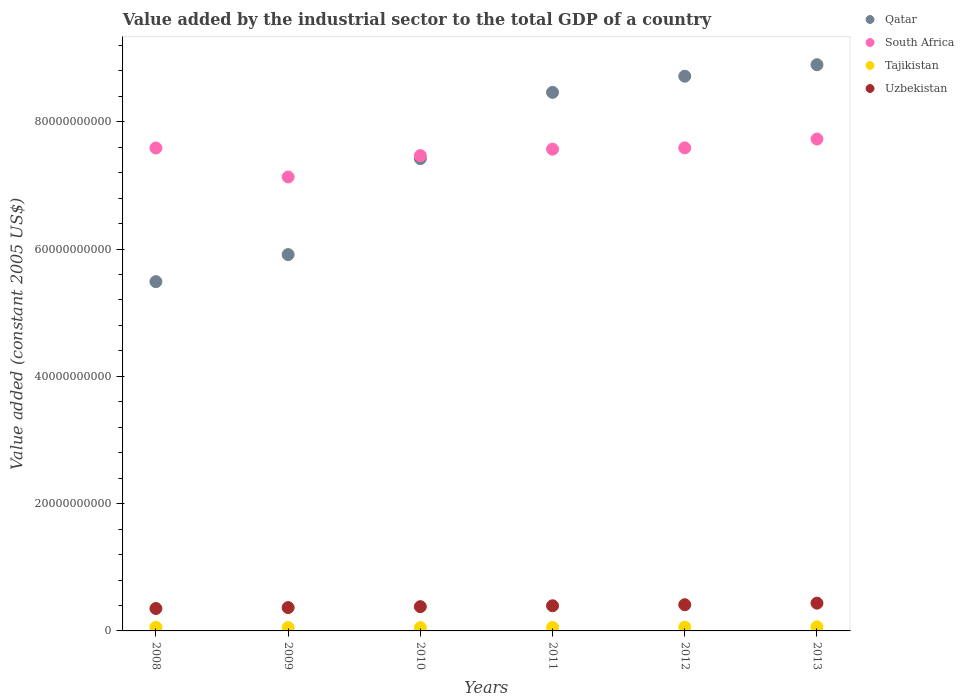What is the value added by the industrial sector in Tajikistan in 2010?
Make the answer very short. 5.19e+08. Across all years, what is the maximum value added by the industrial sector in South Africa?
Give a very brief answer. 7.73e+1. Across all years, what is the minimum value added by the industrial sector in South Africa?
Your answer should be compact. 7.13e+1. In which year was the value added by the industrial sector in Tajikistan maximum?
Ensure brevity in your answer.  2013. In which year was the value added by the industrial sector in Tajikistan minimum?
Provide a succinct answer. 2010. What is the total value added by the industrial sector in Uzbekistan in the graph?
Give a very brief answer. 2.34e+1. What is the difference between the value added by the industrial sector in Uzbekistan in 2008 and that in 2009?
Offer a very short reply. -1.44e+08. What is the difference between the value added by the industrial sector in Tajikistan in 2012 and the value added by the industrial sector in South Africa in 2008?
Your answer should be very brief. -7.53e+1. What is the average value added by the industrial sector in South Africa per year?
Offer a terse response. 7.51e+1. In the year 2010, what is the difference between the value added by the industrial sector in Uzbekistan and value added by the industrial sector in Tajikistan?
Keep it short and to the point. 3.30e+09. In how many years, is the value added by the industrial sector in South Africa greater than 48000000000 US$?
Give a very brief answer. 6. What is the ratio of the value added by the industrial sector in Tajikistan in 2008 to that in 2013?
Ensure brevity in your answer.  0.89. Is the value added by the industrial sector in Qatar in 2009 less than that in 2012?
Offer a terse response. Yes. What is the difference between the highest and the second highest value added by the industrial sector in Tajikistan?
Keep it short and to the point. 5.21e+07. What is the difference between the highest and the lowest value added by the industrial sector in South Africa?
Offer a terse response. 5.96e+09. In how many years, is the value added by the industrial sector in Tajikistan greater than the average value added by the industrial sector in Tajikistan taken over all years?
Your answer should be compact. 3. How many dotlines are there?
Your answer should be compact. 4. How many years are there in the graph?
Your response must be concise. 6. Are the values on the major ticks of Y-axis written in scientific E-notation?
Your answer should be very brief. No. Does the graph contain any zero values?
Provide a short and direct response. No. How many legend labels are there?
Provide a succinct answer. 4. What is the title of the graph?
Keep it short and to the point. Value added by the industrial sector to the total GDP of a country. What is the label or title of the X-axis?
Provide a succinct answer. Years. What is the label or title of the Y-axis?
Your response must be concise. Value added (constant 2005 US$). What is the Value added (constant 2005 US$) in Qatar in 2008?
Ensure brevity in your answer.  5.49e+1. What is the Value added (constant 2005 US$) of South Africa in 2008?
Keep it short and to the point. 7.59e+1. What is the Value added (constant 2005 US$) in Tajikistan in 2008?
Ensure brevity in your answer.  5.72e+08. What is the Value added (constant 2005 US$) in Uzbekistan in 2008?
Your answer should be compact. 3.52e+09. What is the Value added (constant 2005 US$) in Qatar in 2009?
Keep it short and to the point. 5.91e+1. What is the Value added (constant 2005 US$) of South Africa in 2009?
Your response must be concise. 7.13e+1. What is the Value added (constant 2005 US$) in Tajikistan in 2009?
Provide a succinct answer. 5.31e+08. What is the Value added (constant 2005 US$) of Uzbekistan in 2009?
Your response must be concise. 3.67e+09. What is the Value added (constant 2005 US$) in Qatar in 2010?
Provide a short and direct response. 7.42e+1. What is the Value added (constant 2005 US$) in South Africa in 2010?
Your answer should be very brief. 7.47e+1. What is the Value added (constant 2005 US$) of Tajikistan in 2010?
Provide a short and direct response. 5.19e+08. What is the Value added (constant 2005 US$) of Uzbekistan in 2010?
Offer a terse response. 3.81e+09. What is the Value added (constant 2005 US$) of Qatar in 2011?
Your response must be concise. 8.46e+1. What is the Value added (constant 2005 US$) of South Africa in 2011?
Make the answer very short. 7.57e+1. What is the Value added (constant 2005 US$) of Tajikistan in 2011?
Your answer should be compact. 5.49e+08. What is the Value added (constant 2005 US$) of Uzbekistan in 2011?
Your response must be concise. 3.95e+09. What is the Value added (constant 2005 US$) of Qatar in 2012?
Make the answer very short. 8.72e+1. What is the Value added (constant 2005 US$) in South Africa in 2012?
Keep it short and to the point. 7.59e+1. What is the Value added (constant 2005 US$) in Tajikistan in 2012?
Your response must be concise. 5.91e+08. What is the Value added (constant 2005 US$) of Uzbekistan in 2012?
Offer a terse response. 4.12e+09. What is the Value added (constant 2005 US$) of Qatar in 2013?
Provide a short and direct response. 8.90e+1. What is the Value added (constant 2005 US$) of South Africa in 2013?
Provide a succinct answer. 7.73e+1. What is the Value added (constant 2005 US$) of Tajikistan in 2013?
Keep it short and to the point. 6.43e+08. What is the Value added (constant 2005 US$) of Uzbekistan in 2013?
Give a very brief answer. 4.37e+09. Across all years, what is the maximum Value added (constant 2005 US$) of Qatar?
Make the answer very short. 8.90e+1. Across all years, what is the maximum Value added (constant 2005 US$) of South Africa?
Your response must be concise. 7.73e+1. Across all years, what is the maximum Value added (constant 2005 US$) in Tajikistan?
Your response must be concise. 6.43e+08. Across all years, what is the maximum Value added (constant 2005 US$) in Uzbekistan?
Make the answer very short. 4.37e+09. Across all years, what is the minimum Value added (constant 2005 US$) of Qatar?
Provide a succinct answer. 5.49e+1. Across all years, what is the minimum Value added (constant 2005 US$) of South Africa?
Give a very brief answer. 7.13e+1. Across all years, what is the minimum Value added (constant 2005 US$) in Tajikistan?
Your answer should be very brief. 5.19e+08. Across all years, what is the minimum Value added (constant 2005 US$) in Uzbekistan?
Make the answer very short. 3.52e+09. What is the total Value added (constant 2005 US$) of Qatar in the graph?
Give a very brief answer. 4.49e+11. What is the total Value added (constant 2005 US$) of South Africa in the graph?
Provide a succinct answer. 4.51e+11. What is the total Value added (constant 2005 US$) of Tajikistan in the graph?
Offer a terse response. 3.40e+09. What is the total Value added (constant 2005 US$) of Uzbekistan in the graph?
Make the answer very short. 2.34e+1. What is the difference between the Value added (constant 2005 US$) of Qatar in 2008 and that in 2009?
Provide a succinct answer. -4.26e+09. What is the difference between the Value added (constant 2005 US$) of South Africa in 2008 and that in 2009?
Keep it short and to the point. 4.55e+09. What is the difference between the Value added (constant 2005 US$) of Tajikistan in 2008 and that in 2009?
Give a very brief answer. 4.07e+07. What is the difference between the Value added (constant 2005 US$) of Uzbekistan in 2008 and that in 2009?
Ensure brevity in your answer.  -1.44e+08. What is the difference between the Value added (constant 2005 US$) in Qatar in 2008 and that in 2010?
Offer a very short reply. -1.93e+1. What is the difference between the Value added (constant 2005 US$) of South Africa in 2008 and that in 2010?
Provide a succinct answer. 1.19e+09. What is the difference between the Value added (constant 2005 US$) in Tajikistan in 2008 and that in 2010?
Give a very brief answer. 5.35e+07. What is the difference between the Value added (constant 2005 US$) of Uzbekistan in 2008 and that in 2010?
Offer a terse response. -2.91e+08. What is the difference between the Value added (constant 2005 US$) in Qatar in 2008 and that in 2011?
Your answer should be very brief. -2.97e+1. What is the difference between the Value added (constant 2005 US$) of South Africa in 2008 and that in 2011?
Give a very brief answer. 1.84e+08. What is the difference between the Value added (constant 2005 US$) in Tajikistan in 2008 and that in 2011?
Your answer should be very brief. 2.35e+07. What is the difference between the Value added (constant 2005 US$) of Uzbekistan in 2008 and that in 2011?
Provide a short and direct response. -4.29e+08. What is the difference between the Value added (constant 2005 US$) in Qatar in 2008 and that in 2012?
Offer a terse response. -3.23e+1. What is the difference between the Value added (constant 2005 US$) in South Africa in 2008 and that in 2012?
Offer a terse response. -2.52e+07. What is the difference between the Value added (constant 2005 US$) in Tajikistan in 2008 and that in 2012?
Ensure brevity in your answer.  -1.87e+07. What is the difference between the Value added (constant 2005 US$) of Uzbekistan in 2008 and that in 2012?
Give a very brief answer. -5.94e+08. What is the difference between the Value added (constant 2005 US$) of Qatar in 2008 and that in 2013?
Offer a terse response. -3.41e+1. What is the difference between the Value added (constant 2005 US$) in South Africa in 2008 and that in 2013?
Your answer should be compact. -1.41e+09. What is the difference between the Value added (constant 2005 US$) in Tajikistan in 2008 and that in 2013?
Ensure brevity in your answer.  -7.08e+07. What is the difference between the Value added (constant 2005 US$) of Uzbekistan in 2008 and that in 2013?
Your answer should be compact. -8.42e+08. What is the difference between the Value added (constant 2005 US$) of Qatar in 2009 and that in 2010?
Provide a short and direct response. -1.51e+1. What is the difference between the Value added (constant 2005 US$) in South Africa in 2009 and that in 2010?
Your answer should be very brief. -3.36e+09. What is the difference between the Value added (constant 2005 US$) of Tajikistan in 2009 and that in 2010?
Your answer should be compact. 1.28e+07. What is the difference between the Value added (constant 2005 US$) in Uzbekistan in 2009 and that in 2010?
Give a very brief answer. -1.47e+08. What is the difference between the Value added (constant 2005 US$) of Qatar in 2009 and that in 2011?
Offer a very short reply. -2.55e+1. What is the difference between the Value added (constant 2005 US$) in South Africa in 2009 and that in 2011?
Provide a succinct answer. -4.37e+09. What is the difference between the Value added (constant 2005 US$) of Tajikistan in 2009 and that in 2011?
Ensure brevity in your answer.  -1.72e+07. What is the difference between the Value added (constant 2005 US$) in Uzbekistan in 2009 and that in 2011?
Your answer should be compact. -2.84e+08. What is the difference between the Value added (constant 2005 US$) in Qatar in 2009 and that in 2012?
Ensure brevity in your answer.  -2.80e+1. What is the difference between the Value added (constant 2005 US$) of South Africa in 2009 and that in 2012?
Keep it short and to the point. -4.57e+09. What is the difference between the Value added (constant 2005 US$) in Tajikistan in 2009 and that in 2012?
Give a very brief answer. -5.94e+07. What is the difference between the Value added (constant 2005 US$) in Uzbekistan in 2009 and that in 2012?
Provide a succinct answer. -4.50e+08. What is the difference between the Value added (constant 2005 US$) in Qatar in 2009 and that in 2013?
Provide a succinct answer. -2.98e+1. What is the difference between the Value added (constant 2005 US$) in South Africa in 2009 and that in 2013?
Provide a succinct answer. -5.96e+09. What is the difference between the Value added (constant 2005 US$) in Tajikistan in 2009 and that in 2013?
Offer a very short reply. -1.11e+08. What is the difference between the Value added (constant 2005 US$) of Uzbekistan in 2009 and that in 2013?
Provide a succinct answer. -6.97e+08. What is the difference between the Value added (constant 2005 US$) in Qatar in 2010 and that in 2011?
Provide a short and direct response. -1.04e+1. What is the difference between the Value added (constant 2005 US$) of South Africa in 2010 and that in 2011?
Ensure brevity in your answer.  -1.01e+09. What is the difference between the Value added (constant 2005 US$) of Tajikistan in 2010 and that in 2011?
Your answer should be very brief. -3.00e+07. What is the difference between the Value added (constant 2005 US$) in Uzbekistan in 2010 and that in 2011?
Keep it short and to the point. -1.37e+08. What is the difference between the Value added (constant 2005 US$) of Qatar in 2010 and that in 2012?
Offer a terse response. -1.29e+1. What is the difference between the Value added (constant 2005 US$) of South Africa in 2010 and that in 2012?
Make the answer very short. -1.22e+09. What is the difference between the Value added (constant 2005 US$) of Tajikistan in 2010 and that in 2012?
Offer a terse response. -7.22e+07. What is the difference between the Value added (constant 2005 US$) of Uzbekistan in 2010 and that in 2012?
Offer a terse response. -3.03e+08. What is the difference between the Value added (constant 2005 US$) in Qatar in 2010 and that in 2013?
Provide a succinct answer. -1.48e+1. What is the difference between the Value added (constant 2005 US$) in South Africa in 2010 and that in 2013?
Ensure brevity in your answer.  -2.60e+09. What is the difference between the Value added (constant 2005 US$) of Tajikistan in 2010 and that in 2013?
Offer a very short reply. -1.24e+08. What is the difference between the Value added (constant 2005 US$) of Uzbekistan in 2010 and that in 2013?
Your answer should be very brief. -5.50e+08. What is the difference between the Value added (constant 2005 US$) in Qatar in 2011 and that in 2012?
Provide a succinct answer. -2.54e+09. What is the difference between the Value added (constant 2005 US$) in South Africa in 2011 and that in 2012?
Give a very brief answer. -2.09e+08. What is the difference between the Value added (constant 2005 US$) in Tajikistan in 2011 and that in 2012?
Make the answer very short. -4.22e+07. What is the difference between the Value added (constant 2005 US$) in Uzbekistan in 2011 and that in 2012?
Your response must be concise. -1.66e+08. What is the difference between the Value added (constant 2005 US$) in Qatar in 2011 and that in 2013?
Make the answer very short. -4.34e+09. What is the difference between the Value added (constant 2005 US$) in South Africa in 2011 and that in 2013?
Provide a succinct answer. -1.60e+09. What is the difference between the Value added (constant 2005 US$) in Tajikistan in 2011 and that in 2013?
Offer a terse response. -9.43e+07. What is the difference between the Value added (constant 2005 US$) in Uzbekistan in 2011 and that in 2013?
Your answer should be compact. -4.13e+08. What is the difference between the Value added (constant 2005 US$) in Qatar in 2012 and that in 2013?
Your answer should be compact. -1.81e+09. What is the difference between the Value added (constant 2005 US$) in South Africa in 2012 and that in 2013?
Make the answer very short. -1.39e+09. What is the difference between the Value added (constant 2005 US$) in Tajikistan in 2012 and that in 2013?
Give a very brief answer. -5.21e+07. What is the difference between the Value added (constant 2005 US$) of Uzbekistan in 2012 and that in 2013?
Keep it short and to the point. -2.47e+08. What is the difference between the Value added (constant 2005 US$) in Qatar in 2008 and the Value added (constant 2005 US$) in South Africa in 2009?
Provide a succinct answer. -1.65e+1. What is the difference between the Value added (constant 2005 US$) of Qatar in 2008 and the Value added (constant 2005 US$) of Tajikistan in 2009?
Give a very brief answer. 5.44e+1. What is the difference between the Value added (constant 2005 US$) in Qatar in 2008 and the Value added (constant 2005 US$) in Uzbekistan in 2009?
Your answer should be very brief. 5.12e+1. What is the difference between the Value added (constant 2005 US$) in South Africa in 2008 and the Value added (constant 2005 US$) in Tajikistan in 2009?
Your answer should be compact. 7.53e+1. What is the difference between the Value added (constant 2005 US$) in South Africa in 2008 and the Value added (constant 2005 US$) in Uzbekistan in 2009?
Offer a very short reply. 7.22e+1. What is the difference between the Value added (constant 2005 US$) of Tajikistan in 2008 and the Value added (constant 2005 US$) of Uzbekistan in 2009?
Ensure brevity in your answer.  -3.10e+09. What is the difference between the Value added (constant 2005 US$) of Qatar in 2008 and the Value added (constant 2005 US$) of South Africa in 2010?
Offer a very short reply. -1.98e+1. What is the difference between the Value added (constant 2005 US$) of Qatar in 2008 and the Value added (constant 2005 US$) of Tajikistan in 2010?
Offer a very short reply. 5.44e+1. What is the difference between the Value added (constant 2005 US$) of Qatar in 2008 and the Value added (constant 2005 US$) of Uzbekistan in 2010?
Provide a short and direct response. 5.11e+1. What is the difference between the Value added (constant 2005 US$) in South Africa in 2008 and the Value added (constant 2005 US$) in Tajikistan in 2010?
Ensure brevity in your answer.  7.54e+1. What is the difference between the Value added (constant 2005 US$) in South Africa in 2008 and the Value added (constant 2005 US$) in Uzbekistan in 2010?
Keep it short and to the point. 7.21e+1. What is the difference between the Value added (constant 2005 US$) of Tajikistan in 2008 and the Value added (constant 2005 US$) of Uzbekistan in 2010?
Make the answer very short. -3.24e+09. What is the difference between the Value added (constant 2005 US$) in Qatar in 2008 and the Value added (constant 2005 US$) in South Africa in 2011?
Provide a succinct answer. -2.08e+1. What is the difference between the Value added (constant 2005 US$) of Qatar in 2008 and the Value added (constant 2005 US$) of Tajikistan in 2011?
Your answer should be compact. 5.43e+1. What is the difference between the Value added (constant 2005 US$) in Qatar in 2008 and the Value added (constant 2005 US$) in Uzbekistan in 2011?
Give a very brief answer. 5.09e+1. What is the difference between the Value added (constant 2005 US$) of South Africa in 2008 and the Value added (constant 2005 US$) of Tajikistan in 2011?
Provide a short and direct response. 7.53e+1. What is the difference between the Value added (constant 2005 US$) in South Africa in 2008 and the Value added (constant 2005 US$) in Uzbekistan in 2011?
Offer a terse response. 7.19e+1. What is the difference between the Value added (constant 2005 US$) in Tajikistan in 2008 and the Value added (constant 2005 US$) in Uzbekistan in 2011?
Your answer should be compact. -3.38e+09. What is the difference between the Value added (constant 2005 US$) in Qatar in 2008 and the Value added (constant 2005 US$) in South Africa in 2012?
Offer a very short reply. -2.10e+1. What is the difference between the Value added (constant 2005 US$) of Qatar in 2008 and the Value added (constant 2005 US$) of Tajikistan in 2012?
Offer a terse response. 5.43e+1. What is the difference between the Value added (constant 2005 US$) in Qatar in 2008 and the Value added (constant 2005 US$) in Uzbekistan in 2012?
Ensure brevity in your answer.  5.08e+1. What is the difference between the Value added (constant 2005 US$) in South Africa in 2008 and the Value added (constant 2005 US$) in Tajikistan in 2012?
Your response must be concise. 7.53e+1. What is the difference between the Value added (constant 2005 US$) in South Africa in 2008 and the Value added (constant 2005 US$) in Uzbekistan in 2012?
Provide a short and direct response. 7.18e+1. What is the difference between the Value added (constant 2005 US$) of Tajikistan in 2008 and the Value added (constant 2005 US$) of Uzbekistan in 2012?
Offer a terse response. -3.55e+09. What is the difference between the Value added (constant 2005 US$) in Qatar in 2008 and the Value added (constant 2005 US$) in South Africa in 2013?
Provide a succinct answer. -2.24e+1. What is the difference between the Value added (constant 2005 US$) of Qatar in 2008 and the Value added (constant 2005 US$) of Tajikistan in 2013?
Give a very brief answer. 5.42e+1. What is the difference between the Value added (constant 2005 US$) in Qatar in 2008 and the Value added (constant 2005 US$) in Uzbekistan in 2013?
Provide a succinct answer. 5.05e+1. What is the difference between the Value added (constant 2005 US$) in South Africa in 2008 and the Value added (constant 2005 US$) in Tajikistan in 2013?
Offer a very short reply. 7.52e+1. What is the difference between the Value added (constant 2005 US$) in South Africa in 2008 and the Value added (constant 2005 US$) in Uzbekistan in 2013?
Your answer should be very brief. 7.15e+1. What is the difference between the Value added (constant 2005 US$) in Tajikistan in 2008 and the Value added (constant 2005 US$) in Uzbekistan in 2013?
Provide a succinct answer. -3.79e+09. What is the difference between the Value added (constant 2005 US$) of Qatar in 2009 and the Value added (constant 2005 US$) of South Africa in 2010?
Your response must be concise. -1.56e+1. What is the difference between the Value added (constant 2005 US$) of Qatar in 2009 and the Value added (constant 2005 US$) of Tajikistan in 2010?
Ensure brevity in your answer.  5.86e+1. What is the difference between the Value added (constant 2005 US$) of Qatar in 2009 and the Value added (constant 2005 US$) of Uzbekistan in 2010?
Your answer should be very brief. 5.53e+1. What is the difference between the Value added (constant 2005 US$) in South Africa in 2009 and the Value added (constant 2005 US$) in Tajikistan in 2010?
Offer a terse response. 7.08e+1. What is the difference between the Value added (constant 2005 US$) in South Africa in 2009 and the Value added (constant 2005 US$) in Uzbekistan in 2010?
Give a very brief answer. 6.75e+1. What is the difference between the Value added (constant 2005 US$) of Tajikistan in 2009 and the Value added (constant 2005 US$) of Uzbekistan in 2010?
Offer a terse response. -3.28e+09. What is the difference between the Value added (constant 2005 US$) of Qatar in 2009 and the Value added (constant 2005 US$) of South Africa in 2011?
Give a very brief answer. -1.66e+1. What is the difference between the Value added (constant 2005 US$) of Qatar in 2009 and the Value added (constant 2005 US$) of Tajikistan in 2011?
Make the answer very short. 5.86e+1. What is the difference between the Value added (constant 2005 US$) of Qatar in 2009 and the Value added (constant 2005 US$) of Uzbekistan in 2011?
Your answer should be very brief. 5.52e+1. What is the difference between the Value added (constant 2005 US$) in South Africa in 2009 and the Value added (constant 2005 US$) in Tajikistan in 2011?
Offer a terse response. 7.08e+1. What is the difference between the Value added (constant 2005 US$) in South Africa in 2009 and the Value added (constant 2005 US$) in Uzbekistan in 2011?
Provide a short and direct response. 6.74e+1. What is the difference between the Value added (constant 2005 US$) of Tajikistan in 2009 and the Value added (constant 2005 US$) of Uzbekistan in 2011?
Your response must be concise. -3.42e+09. What is the difference between the Value added (constant 2005 US$) of Qatar in 2009 and the Value added (constant 2005 US$) of South Africa in 2012?
Make the answer very short. -1.68e+1. What is the difference between the Value added (constant 2005 US$) of Qatar in 2009 and the Value added (constant 2005 US$) of Tajikistan in 2012?
Give a very brief answer. 5.85e+1. What is the difference between the Value added (constant 2005 US$) of Qatar in 2009 and the Value added (constant 2005 US$) of Uzbekistan in 2012?
Provide a succinct answer. 5.50e+1. What is the difference between the Value added (constant 2005 US$) in South Africa in 2009 and the Value added (constant 2005 US$) in Tajikistan in 2012?
Your answer should be compact. 7.07e+1. What is the difference between the Value added (constant 2005 US$) of South Africa in 2009 and the Value added (constant 2005 US$) of Uzbekistan in 2012?
Give a very brief answer. 6.72e+1. What is the difference between the Value added (constant 2005 US$) of Tajikistan in 2009 and the Value added (constant 2005 US$) of Uzbekistan in 2012?
Keep it short and to the point. -3.59e+09. What is the difference between the Value added (constant 2005 US$) in Qatar in 2009 and the Value added (constant 2005 US$) in South Africa in 2013?
Your answer should be very brief. -1.82e+1. What is the difference between the Value added (constant 2005 US$) in Qatar in 2009 and the Value added (constant 2005 US$) in Tajikistan in 2013?
Your answer should be very brief. 5.85e+1. What is the difference between the Value added (constant 2005 US$) of Qatar in 2009 and the Value added (constant 2005 US$) of Uzbekistan in 2013?
Provide a short and direct response. 5.48e+1. What is the difference between the Value added (constant 2005 US$) in South Africa in 2009 and the Value added (constant 2005 US$) in Tajikistan in 2013?
Your response must be concise. 7.07e+1. What is the difference between the Value added (constant 2005 US$) in South Africa in 2009 and the Value added (constant 2005 US$) in Uzbekistan in 2013?
Offer a very short reply. 6.70e+1. What is the difference between the Value added (constant 2005 US$) in Tajikistan in 2009 and the Value added (constant 2005 US$) in Uzbekistan in 2013?
Provide a short and direct response. -3.83e+09. What is the difference between the Value added (constant 2005 US$) of Qatar in 2010 and the Value added (constant 2005 US$) of South Africa in 2011?
Keep it short and to the point. -1.48e+09. What is the difference between the Value added (constant 2005 US$) in Qatar in 2010 and the Value added (constant 2005 US$) in Tajikistan in 2011?
Your answer should be very brief. 7.37e+1. What is the difference between the Value added (constant 2005 US$) of Qatar in 2010 and the Value added (constant 2005 US$) of Uzbekistan in 2011?
Offer a very short reply. 7.03e+1. What is the difference between the Value added (constant 2005 US$) of South Africa in 2010 and the Value added (constant 2005 US$) of Tajikistan in 2011?
Ensure brevity in your answer.  7.41e+1. What is the difference between the Value added (constant 2005 US$) of South Africa in 2010 and the Value added (constant 2005 US$) of Uzbekistan in 2011?
Make the answer very short. 7.07e+1. What is the difference between the Value added (constant 2005 US$) in Tajikistan in 2010 and the Value added (constant 2005 US$) in Uzbekistan in 2011?
Your answer should be compact. -3.43e+09. What is the difference between the Value added (constant 2005 US$) in Qatar in 2010 and the Value added (constant 2005 US$) in South Africa in 2012?
Your answer should be compact. -1.69e+09. What is the difference between the Value added (constant 2005 US$) in Qatar in 2010 and the Value added (constant 2005 US$) in Tajikistan in 2012?
Your answer should be very brief. 7.36e+1. What is the difference between the Value added (constant 2005 US$) in Qatar in 2010 and the Value added (constant 2005 US$) in Uzbekistan in 2012?
Provide a succinct answer. 7.01e+1. What is the difference between the Value added (constant 2005 US$) of South Africa in 2010 and the Value added (constant 2005 US$) of Tajikistan in 2012?
Your answer should be very brief. 7.41e+1. What is the difference between the Value added (constant 2005 US$) in South Africa in 2010 and the Value added (constant 2005 US$) in Uzbekistan in 2012?
Make the answer very short. 7.06e+1. What is the difference between the Value added (constant 2005 US$) of Tajikistan in 2010 and the Value added (constant 2005 US$) of Uzbekistan in 2012?
Your answer should be very brief. -3.60e+09. What is the difference between the Value added (constant 2005 US$) of Qatar in 2010 and the Value added (constant 2005 US$) of South Africa in 2013?
Make the answer very short. -3.08e+09. What is the difference between the Value added (constant 2005 US$) in Qatar in 2010 and the Value added (constant 2005 US$) in Tajikistan in 2013?
Offer a terse response. 7.36e+1. What is the difference between the Value added (constant 2005 US$) in Qatar in 2010 and the Value added (constant 2005 US$) in Uzbekistan in 2013?
Offer a very short reply. 6.99e+1. What is the difference between the Value added (constant 2005 US$) of South Africa in 2010 and the Value added (constant 2005 US$) of Tajikistan in 2013?
Ensure brevity in your answer.  7.40e+1. What is the difference between the Value added (constant 2005 US$) in South Africa in 2010 and the Value added (constant 2005 US$) in Uzbekistan in 2013?
Ensure brevity in your answer.  7.03e+1. What is the difference between the Value added (constant 2005 US$) of Tajikistan in 2010 and the Value added (constant 2005 US$) of Uzbekistan in 2013?
Give a very brief answer. -3.85e+09. What is the difference between the Value added (constant 2005 US$) in Qatar in 2011 and the Value added (constant 2005 US$) in South Africa in 2012?
Keep it short and to the point. 8.72e+09. What is the difference between the Value added (constant 2005 US$) in Qatar in 2011 and the Value added (constant 2005 US$) in Tajikistan in 2012?
Offer a very short reply. 8.40e+1. What is the difference between the Value added (constant 2005 US$) in Qatar in 2011 and the Value added (constant 2005 US$) in Uzbekistan in 2012?
Offer a very short reply. 8.05e+1. What is the difference between the Value added (constant 2005 US$) of South Africa in 2011 and the Value added (constant 2005 US$) of Tajikistan in 2012?
Make the answer very short. 7.51e+1. What is the difference between the Value added (constant 2005 US$) in South Africa in 2011 and the Value added (constant 2005 US$) in Uzbekistan in 2012?
Ensure brevity in your answer.  7.16e+1. What is the difference between the Value added (constant 2005 US$) in Tajikistan in 2011 and the Value added (constant 2005 US$) in Uzbekistan in 2012?
Keep it short and to the point. -3.57e+09. What is the difference between the Value added (constant 2005 US$) of Qatar in 2011 and the Value added (constant 2005 US$) of South Africa in 2013?
Your answer should be compact. 7.33e+09. What is the difference between the Value added (constant 2005 US$) in Qatar in 2011 and the Value added (constant 2005 US$) in Tajikistan in 2013?
Your answer should be very brief. 8.40e+1. What is the difference between the Value added (constant 2005 US$) in Qatar in 2011 and the Value added (constant 2005 US$) in Uzbekistan in 2013?
Provide a short and direct response. 8.03e+1. What is the difference between the Value added (constant 2005 US$) of South Africa in 2011 and the Value added (constant 2005 US$) of Tajikistan in 2013?
Your answer should be compact. 7.51e+1. What is the difference between the Value added (constant 2005 US$) of South Africa in 2011 and the Value added (constant 2005 US$) of Uzbekistan in 2013?
Offer a terse response. 7.13e+1. What is the difference between the Value added (constant 2005 US$) of Tajikistan in 2011 and the Value added (constant 2005 US$) of Uzbekistan in 2013?
Make the answer very short. -3.82e+09. What is the difference between the Value added (constant 2005 US$) of Qatar in 2012 and the Value added (constant 2005 US$) of South Africa in 2013?
Your response must be concise. 9.87e+09. What is the difference between the Value added (constant 2005 US$) in Qatar in 2012 and the Value added (constant 2005 US$) in Tajikistan in 2013?
Your answer should be compact. 8.65e+1. What is the difference between the Value added (constant 2005 US$) of Qatar in 2012 and the Value added (constant 2005 US$) of Uzbekistan in 2013?
Your answer should be very brief. 8.28e+1. What is the difference between the Value added (constant 2005 US$) in South Africa in 2012 and the Value added (constant 2005 US$) in Tajikistan in 2013?
Keep it short and to the point. 7.53e+1. What is the difference between the Value added (constant 2005 US$) of South Africa in 2012 and the Value added (constant 2005 US$) of Uzbekistan in 2013?
Offer a very short reply. 7.15e+1. What is the difference between the Value added (constant 2005 US$) in Tajikistan in 2012 and the Value added (constant 2005 US$) in Uzbekistan in 2013?
Your response must be concise. -3.77e+09. What is the average Value added (constant 2005 US$) in Qatar per year?
Keep it short and to the point. 7.48e+1. What is the average Value added (constant 2005 US$) in South Africa per year?
Offer a terse response. 7.51e+1. What is the average Value added (constant 2005 US$) in Tajikistan per year?
Keep it short and to the point. 5.67e+08. What is the average Value added (constant 2005 US$) in Uzbekistan per year?
Provide a succinct answer. 3.91e+09. In the year 2008, what is the difference between the Value added (constant 2005 US$) in Qatar and Value added (constant 2005 US$) in South Africa?
Provide a succinct answer. -2.10e+1. In the year 2008, what is the difference between the Value added (constant 2005 US$) in Qatar and Value added (constant 2005 US$) in Tajikistan?
Your answer should be very brief. 5.43e+1. In the year 2008, what is the difference between the Value added (constant 2005 US$) of Qatar and Value added (constant 2005 US$) of Uzbekistan?
Your answer should be very brief. 5.14e+1. In the year 2008, what is the difference between the Value added (constant 2005 US$) in South Africa and Value added (constant 2005 US$) in Tajikistan?
Keep it short and to the point. 7.53e+1. In the year 2008, what is the difference between the Value added (constant 2005 US$) of South Africa and Value added (constant 2005 US$) of Uzbekistan?
Give a very brief answer. 7.24e+1. In the year 2008, what is the difference between the Value added (constant 2005 US$) of Tajikistan and Value added (constant 2005 US$) of Uzbekistan?
Provide a short and direct response. -2.95e+09. In the year 2009, what is the difference between the Value added (constant 2005 US$) of Qatar and Value added (constant 2005 US$) of South Africa?
Give a very brief answer. -1.22e+1. In the year 2009, what is the difference between the Value added (constant 2005 US$) in Qatar and Value added (constant 2005 US$) in Tajikistan?
Ensure brevity in your answer.  5.86e+1. In the year 2009, what is the difference between the Value added (constant 2005 US$) of Qatar and Value added (constant 2005 US$) of Uzbekistan?
Offer a terse response. 5.55e+1. In the year 2009, what is the difference between the Value added (constant 2005 US$) of South Africa and Value added (constant 2005 US$) of Tajikistan?
Offer a terse response. 7.08e+1. In the year 2009, what is the difference between the Value added (constant 2005 US$) of South Africa and Value added (constant 2005 US$) of Uzbekistan?
Provide a succinct answer. 6.77e+1. In the year 2009, what is the difference between the Value added (constant 2005 US$) in Tajikistan and Value added (constant 2005 US$) in Uzbekistan?
Provide a short and direct response. -3.14e+09. In the year 2010, what is the difference between the Value added (constant 2005 US$) of Qatar and Value added (constant 2005 US$) of South Africa?
Make the answer very short. -4.74e+08. In the year 2010, what is the difference between the Value added (constant 2005 US$) in Qatar and Value added (constant 2005 US$) in Tajikistan?
Give a very brief answer. 7.37e+1. In the year 2010, what is the difference between the Value added (constant 2005 US$) of Qatar and Value added (constant 2005 US$) of Uzbekistan?
Offer a very short reply. 7.04e+1. In the year 2010, what is the difference between the Value added (constant 2005 US$) in South Africa and Value added (constant 2005 US$) in Tajikistan?
Offer a terse response. 7.42e+1. In the year 2010, what is the difference between the Value added (constant 2005 US$) in South Africa and Value added (constant 2005 US$) in Uzbekistan?
Offer a terse response. 7.09e+1. In the year 2010, what is the difference between the Value added (constant 2005 US$) of Tajikistan and Value added (constant 2005 US$) of Uzbekistan?
Provide a short and direct response. -3.30e+09. In the year 2011, what is the difference between the Value added (constant 2005 US$) of Qatar and Value added (constant 2005 US$) of South Africa?
Keep it short and to the point. 8.93e+09. In the year 2011, what is the difference between the Value added (constant 2005 US$) of Qatar and Value added (constant 2005 US$) of Tajikistan?
Give a very brief answer. 8.41e+1. In the year 2011, what is the difference between the Value added (constant 2005 US$) of Qatar and Value added (constant 2005 US$) of Uzbekistan?
Provide a short and direct response. 8.07e+1. In the year 2011, what is the difference between the Value added (constant 2005 US$) in South Africa and Value added (constant 2005 US$) in Tajikistan?
Your answer should be compact. 7.51e+1. In the year 2011, what is the difference between the Value added (constant 2005 US$) in South Africa and Value added (constant 2005 US$) in Uzbekistan?
Provide a short and direct response. 7.17e+1. In the year 2011, what is the difference between the Value added (constant 2005 US$) of Tajikistan and Value added (constant 2005 US$) of Uzbekistan?
Give a very brief answer. -3.40e+09. In the year 2012, what is the difference between the Value added (constant 2005 US$) of Qatar and Value added (constant 2005 US$) of South Africa?
Provide a short and direct response. 1.13e+1. In the year 2012, what is the difference between the Value added (constant 2005 US$) of Qatar and Value added (constant 2005 US$) of Tajikistan?
Provide a succinct answer. 8.66e+1. In the year 2012, what is the difference between the Value added (constant 2005 US$) in Qatar and Value added (constant 2005 US$) in Uzbekistan?
Keep it short and to the point. 8.30e+1. In the year 2012, what is the difference between the Value added (constant 2005 US$) in South Africa and Value added (constant 2005 US$) in Tajikistan?
Keep it short and to the point. 7.53e+1. In the year 2012, what is the difference between the Value added (constant 2005 US$) in South Africa and Value added (constant 2005 US$) in Uzbekistan?
Make the answer very short. 7.18e+1. In the year 2012, what is the difference between the Value added (constant 2005 US$) in Tajikistan and Value added (constant 2005 US$) in Uzbekistan?
Give a very brief answer. -3.53e+09. In the year 2013, what is the difference between the Value added (constant 2005 US$) in Qatar and Value added (constant 2005 US$) in South Africa?
Provide a short and direct response. 1.17e+1. In the year 2013, what is the difference between the Value added (constant 2005 US$) of Qatar and Value added (constant 2005 US$) of Tajikistan?
Make the answer very short. 8.83e+1. In the year 2013, what is the difference between the Value added (constant 2005 US$) of Qatar and Value added (constant 2005 US$) of Uzbekistan?
Your answer should be compact. 8.46e+1. In the year 2013, what is the difference between the Value added (constant 2005 US$) of South Africa and Value added (constant 2005 US$) of Tajikistan?
Your response must be concise. 7.67e+1. In the year 2013, what is the difference between the Value added (constant 2005 US$) of South Africa and Value added (constant 2005 US$) of Uzbekistan?
Provide a short and direct response. 7.29e+1. In the year 2013, what is the difference between the Value added (constant 2005 US$) of Tajikistan and Value added (constant 2005 US$) of Uzbekistan?
Provide a short and direct response. -3.72e+09. What is the ratio of the Value added (constant 2005 US$) in Qatar in 2008 to that in 2009?
Give a very brief answer. 0.93. What is the ratio of the Value added (constant 2005 US$) of South Africa in 2008 to that in 2009?
Keep it short and to the point. 1.06. What is the ratio of the Value added (constant 2005 US$) of Tajikistan in 2008 to that in 2009?
Provide a short and direct response. 1.08. What is the ratio of the Value added (constant 2005 US$) in Uzbekistan in 2008 to that in 2009?
Offer a very short reply. 0.96. What is the ratio of the Value added (constant 2005 US$) in Qatar in 2008 to that in 2010?
Keep it short and to the point. 0.74. What is the ratio of the Value added (constant 2005 US$) in South Africa in 2008 to that in 2010?
Provide a short and direct response. 1.02. What is the ratio of the Value added (constant 2005 US$) of Tajikistan in 2008 to that in 2010?
Give a very brief answer. 1.1. What is the ratio of the Value added (constant 2005 US$) in Uzbekistan in 2008 to that in 2010?
Provide a succinct answer. 0.92. What is the ratio of the Value added (constant 2005 US$) in Qatar in 2008 to that in 2011?
Your answer should be very brief. 0.65. What is the ratio of the Value added (constant 2005 US$) in Tajikistan in 2008 to that in 2011?
Give a very brief answer. 1.04. What is the ratio of the Value added (constant 2005 US$) in Uzbekistan in 2008 to that in 2011?
Make the answer very short. 0.89. What is the ratio of the Value added (constant 2005 US$) of Qatar in 2008 to that in 2012?
Your response must be concise. 0.63. What is the ratio of the Value added (constant 2005 US$) of South Africa in 2008 to that in 2012?
Ensure brevity in your answer.  1. What is the ratio of the Value added (constant 2005 US$) in Tajikistan in 2008 to that in 2012?
Keep it short and to the point. 0.97. What is the ratio of the Value added (constant 2005 US$) of Uzbekistan in 2008 to that in 2012?
Keep it short and to the point. 0.86. What is the ratio of the Value added (constant 2005 US$) of Qatar in 2008 to that in 2013?
Offer a terse response. 0.62. What is the ratio of the Value added (constant 2005 US$) of South Africa in 2008 to that in 2013?
Provide a short and direct response. 0.98. What is the ratio of the Value added (constant 2005 US$) in Tajikistan in 2008 to that in 2013?
Give a very brief answer. 0.89. What is the ratio of the Value added (constant 2005 US$) of Uzbekistan in 2008 to that in 2013?
Ensure brevity in your answer.  0.81. What is the ratio of the Value added (constant 2005 US$) in Qatar in 2009 to that in 2010?
Ensure brevity in your answer.  0.8. What is the ratio of the Value added (constant 2005 US$) of South Africa in 2009 to that in 2010?
Offer a terse response. 0.95. What is the ratio of the Value added (constant 2005 US$) in Tajikistan in 2009 to that in 2010?
Provide a short and direct response. 1.02. What is the ratio of the Value added (constant 2005 US$) in Uzbekistan in 2009 to that in 2010?
Keep it short and to the point. 0.96. What is the ratio of the Value added (constant 2005 US$) in Qatar in 2009 to that in 2011?
Give a very brief answer. 0.7. What is the ratio of the Value added (constant 2005 US$) of South Africa in 2009 to that in 2011?
Offer a terse response. 0.94. What is the ratio of the Value added (constant 2005 US$) in Tajikistan in 2009 to that in 2011?
Your answer should be compact. 0.97. What is the ratio of the Value added (constant 2005 US$) of Uzbekistan in 2009 to that in 2011?
Your answer should be compact. 0.93. What is the ratio of the Value added (constant 2005 US$) in Qatar in 2009 to that in 2012?
Provide a short and direct response. 0.68. What is the ratio of the Value added (constant 2005 US$) in South Africa in 2009 to that in 2012?
Make the answer very short. 0.94. What is the ratio of the Value added (constant 2005 US$) in Tajikistan in 2009 to that in 2012?
Your response must be concise. 0.9. What is the ratio of the Value added (constant 2005 US$) of Uzbekistan in 2009 to that in 2012?
Your answer should be very brief. 0.89. What is the ratio of the Value added (constant 2005 US$) of Qatar in 2009 to that in 2013?
Provide a succinct answer. 0.66. What is the ratio of the Value added (constant 2005 US$) of South Africa in 2009 to that in 2013?
Your answer should be very brief. 0.92. What is the ratio of the Value added (constant 2005 US$) in Tajikistan in 2009 to that in 2013?
Offer a terse response. 0.83. What is the ratio of the Value added (constant 2005 US$) in Uzbekistan in 2009 to that in 2013?
Ensure brevity in your answer.  0.84. What is the ratio of the Value added (constant 2005 US$) in Qatar in 2010 to that in 2011?
Offer a very short reply. 0.88. What is the ratio of the Value added (constant 2005 US$) in South Africa in 2010 to that in 2011?
Provide a succinct answer. 0.99. What is the ratio of the Value added (constant 2005 US$) of Tajikistan in 2010 to that in 2011?
Offer a terse response. 0.95. What is the ratio of the Value added (constant 2005 US$) of Uzbekistan in 2010 to that in 2011?
Your answer should be very brief. 0.97. What is the ratio of the Value added (constant 2005 US$) in Qatar in 2010 to that in 2012?
Keep it short and to the point. 0.85. What is the ratio of the Value added (constant 2005 US$) in South Africa in 2010 to that in 2012?
Your answer should be very brief. 0.98. What is the ratio of the Value added (constant 2005 US$) in Tajikistan in 2010 to that in 2012?
Offer a very short reply. 0.88. What is the ratio of the Value added (constant 2005 US$) of Uzbekistan in 2010 to that in 2012?
Keep it short and to the point. 0.93. What is the ratio of the Value added (constant 2005 US$) of Qatar in 2010 to that in 2013?
Ensure brevity in your answer.  0.83. What is the ratio of the Value added (constant 2005 US$) of South Africa in 2010 to that in 2013?
Make the answer very short. 0.97. What is the ratio of the Value added (constant 2005 US$) in Tajikistan in 2010 to that in 2013?
Make the answer very short. 0.81. What is the ratio of the Value added (constant 2005 US$) of Uzbekistan in 2010 to that in 2013?
Your answer should be very brief. 0.87. What is the ratio of the Value added (constant 2005 US$) in Qatar in 2011 to that in 2012?
Keep it short and to the point. 0.97. What is the ratio of the Value added (constant 2005 US$) of Tajikistan in 2011 to that in 2012?
Your answer should be compact. 0.93. What is the ratio of the Value added (constant 2005 US$) of Uzbekistan in 2011 to that in 2012?
Ensure brevity in your answer.  0.96. What is the ratio of the Value added (constant 2005 US$) in Qatar in 2011 to that in 2013?
Ensure brevity in your answer.  0.95. What is the ratio of the Value added (constant 2005 US$) in South Africa in 2011 to that in 2013?
Offer a very short reply. 0.98. What is the ratio of the Value added (constant 2005 US$) of Tajikistan in 2011 to that in 2013?
Ensure brevity in your answer.  0.85. What is the ratio of the Value added (constant 2005 US$) of Uzbekistan in 2011 to that in 2013?
Give a very brief answer. 0.91. What is the ratio of the Value added (constant 2005 US$) of Qatar in 2012 to that in 2013?
Your answer should be very brief. 0.98. What is the ratio of the Value added (constant 2005 US$) of South Africa in 2012 to that in 2013?
Provide a short and direct response. 0.98. What is the ratio of the Value added (constant 2005 US$) of Tajikistan in 2012 to that in 2013?
Your answer should be compact. 0.92. What is the ratio of the Value added (constant 2005 US$) in Uzbekistan in 2012 to that in 2013?
Your answer should be compact. 0.94. What is the difference between the highest and the second highest Value added (constant 2005 US$) of Qatar?
Give a very brief answer. 1.81e+09. What is the difference between the highest and the second highest Value added (constant 2005 US$) in South Africa?
Make the answer very short. 1.39e+09. What is the difference between the highest and the second highest Value added (constant 2005 US$) in Tajikistan?
Your response must be concise. 5.21e+07. What is the difference between the highest and the second highest Value added (constant 2005 US$) of Uzbekistan?
Offer a very short reply. 2.47e+08. What is the difference between the highest and the lowest Value added (constant 2005 US$) in Qatar?
Offer a terse response. 3.41e+1. What is the difference between the highest and the lowest Value added (constant 2005 US$) in South Africa?
Give a very brief answer. 5.96e+09. What is the difference between the highest and the lowest Value added (constant 2005 US$) in Tajikistan?
Your response must be concise. 1.24e+08. What is the difference between the highest and the lowest Value added (constant 2005 US$) of Uzbekistan?
Give a very brief answer. 8.42e+08. 